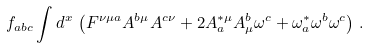<formula> <loc_0><loc_0><loc_500><loc_500>f _ { a b c } \int d ^ { x } \, \left ( F ^ { \nu \mu a } A ^ { b \mu } A ^ { c \nu } + 2 A ^ { * \mu } _ { a } A ^ { b } _ { \mu } \omega ^ { c } + \omega ^ { * } _ { a } \omega ^ { b } \omega ^ { c } \right ) \, .</formula> 